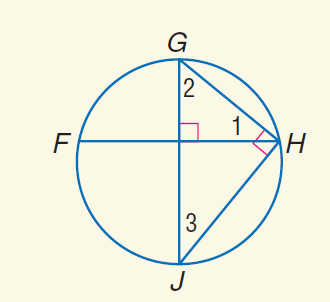Answer the mathemtical geometry problem and directly provide the correct option letter.
Question: m \widehat G H = 78. Find m \angle 3.
Choices: A: 39 B: 66 C: 78 D: 114 A 